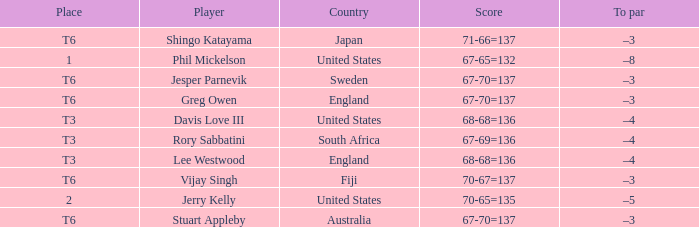Name the score for fiji 70-67=137. 